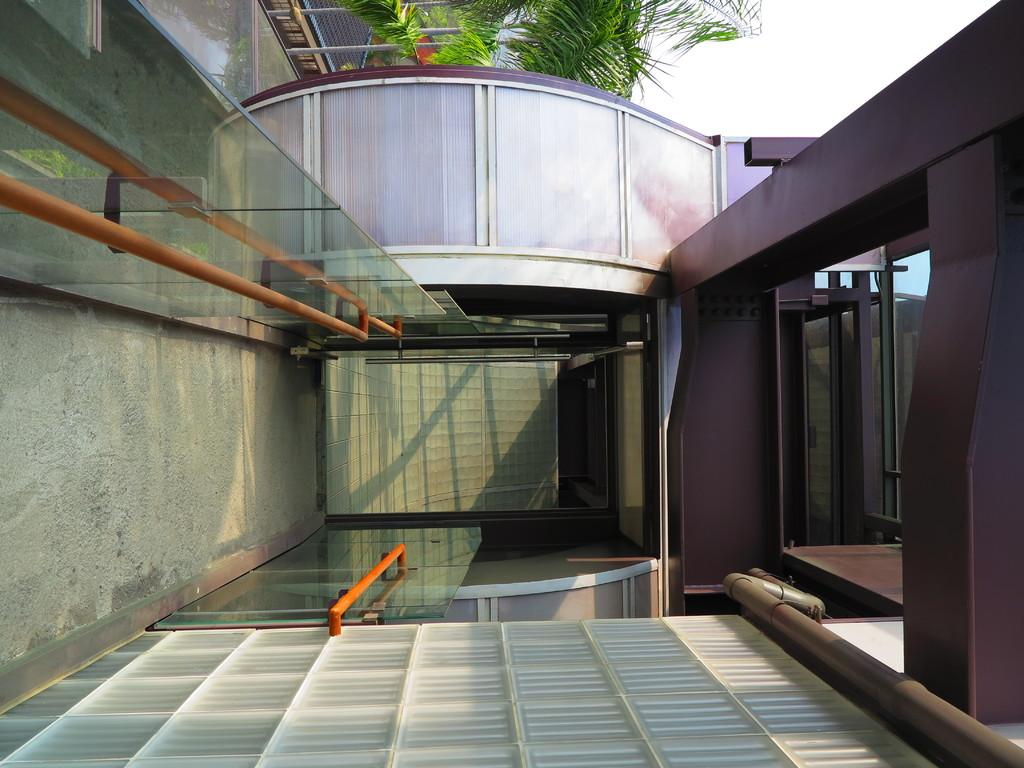What type of structure is present in the image? There is a building in the picture. What natural element can be seen in the image? There is a tree in the picture. How would you describe the weather in the image? The sky is cloudy in the picture. What type of sand can be seen on the building in the image? There is no sand present in the image, and the building is not covered in sand. 